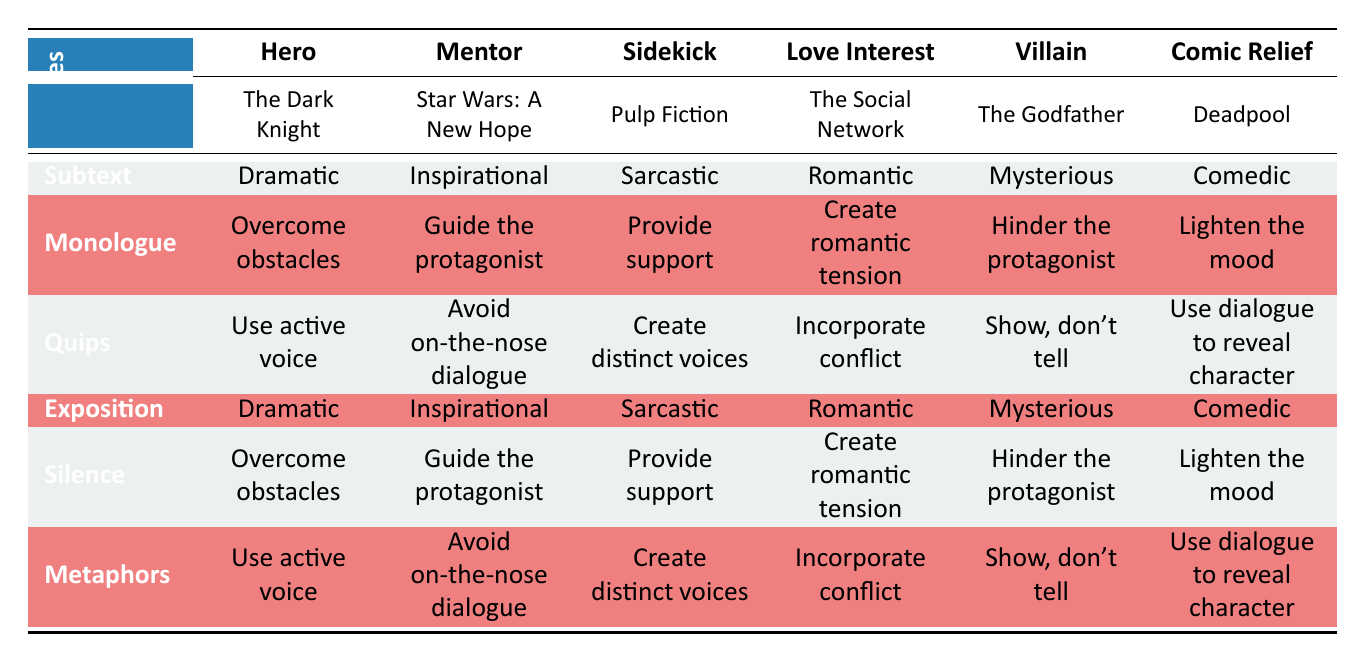What dialogue technique is associated with the Hero archetype? According to the table, the dialogue technique associated with the Hero archetype is "Subtext." This is specifically located in the first row under the Hero column.
Answer: Subtext Which film example is linked to the Sidekick character? The film example linked to the Sidekick character is "Pulp Fiction," as indicated in the second row corresponding to the Sidekick archetype.
Answer: Pulp Fiction Does the Mentors’ dialogue technique utilize Monologue? Yes, the Mentor character utilizes Monologue as a dialogue technique, as it is listed under the Mentor column in the Monologue row.
Answer: Yes What tone is used for the dialogue technique "Silence" in the context of the Villain? The tone used for the dialogue technique "Silence" in relation to the Villain character is "Mysterious," which can be found in the row for Silence under the Villain column.
Answer: Mysterious Compare the dialogue techniques of Hero and Love Interest archetypes for the technique "Exposition." For the Love Interest, "Exposition" has a Romantic tone, while for the Hero, it has a Dramatic tone. This indicates that the same dialogue technique conveys different emotional layers depending on the character.
Answer: Dramatic, Romantic What is the common goal shared between the Hero and Sidekick characters? Both the Hero and Sidekick characters share the common goal of "Overcome obstacles," as listed in the Monologue and Silence rows respectively.
Answer: Overcome obstacles Which character uses the technique "Quips" and what screenwriting tip is specifically associated with that technique? The character archetype that uses "Quips" is the Sidekick, and the screenwriting tip associated with this technique is "Create distinct voices." This can be observed in the corresponding rows for Quips under Sidekick and the associated tip.
Answer: Create distinct voices What is the primary character goal for the Villain archetype? The primary character goal for the Villain archetype is "Hinder the protagonist," as can be seen in the second Monologue row corresponding to the Villain character.
Answer: Hinder the protagonist Is the character goal for the Love Interest the same as the Comic Relief? No, the goal for the Love Interest is "Create romantic tension," which is different from the Comic Relief's goal of "Lighten the mood," demonstrated in the respective goals in the table.
Answer: No 